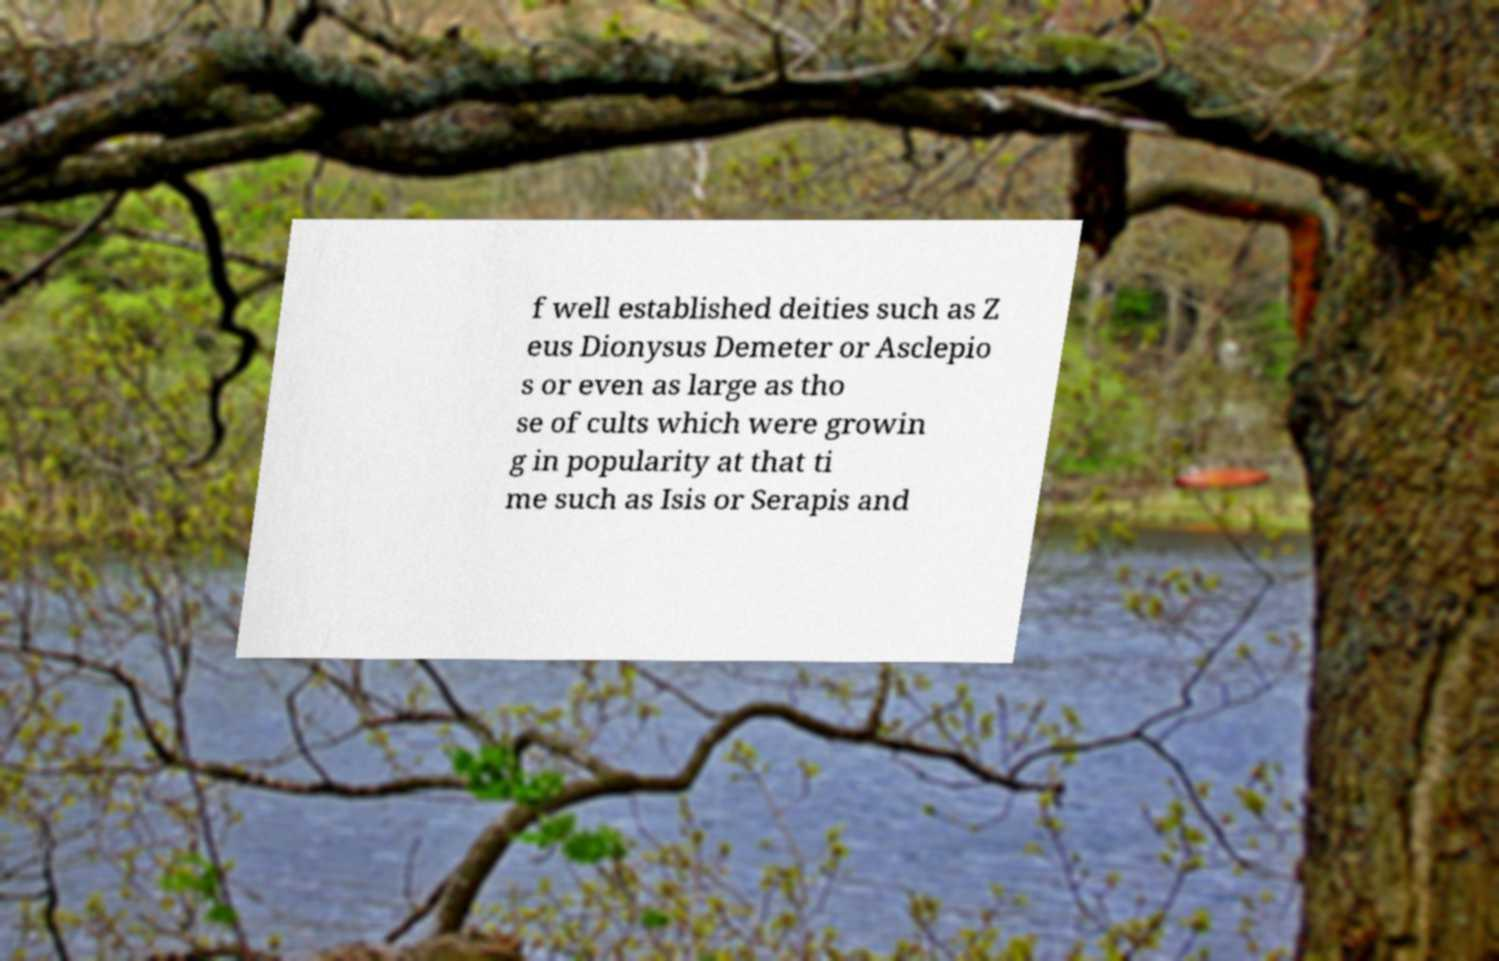What messages or text are displayed in this image? I need them in a readable, typed format. f well established deities such as Z eus Dionysus Demeter or Asclepio s or even as large as tho se of cults which were growin g in popularity at that ti me such as Isis or Serapis and 